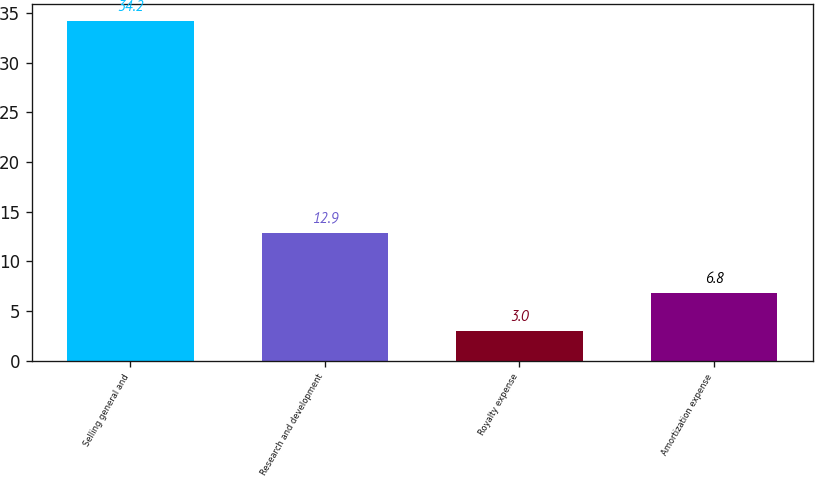Convert chart. <chart><loc_0><loc_0><loc_500><loc_500><bar_chart><fcel>Selling general and<fcel>Research and development<fcel>Royalty expense<fcel>Amortization expense<nl><fcel>34.2<fcel>12.9<fcel>3<fcel>6.8<nl></chart> 